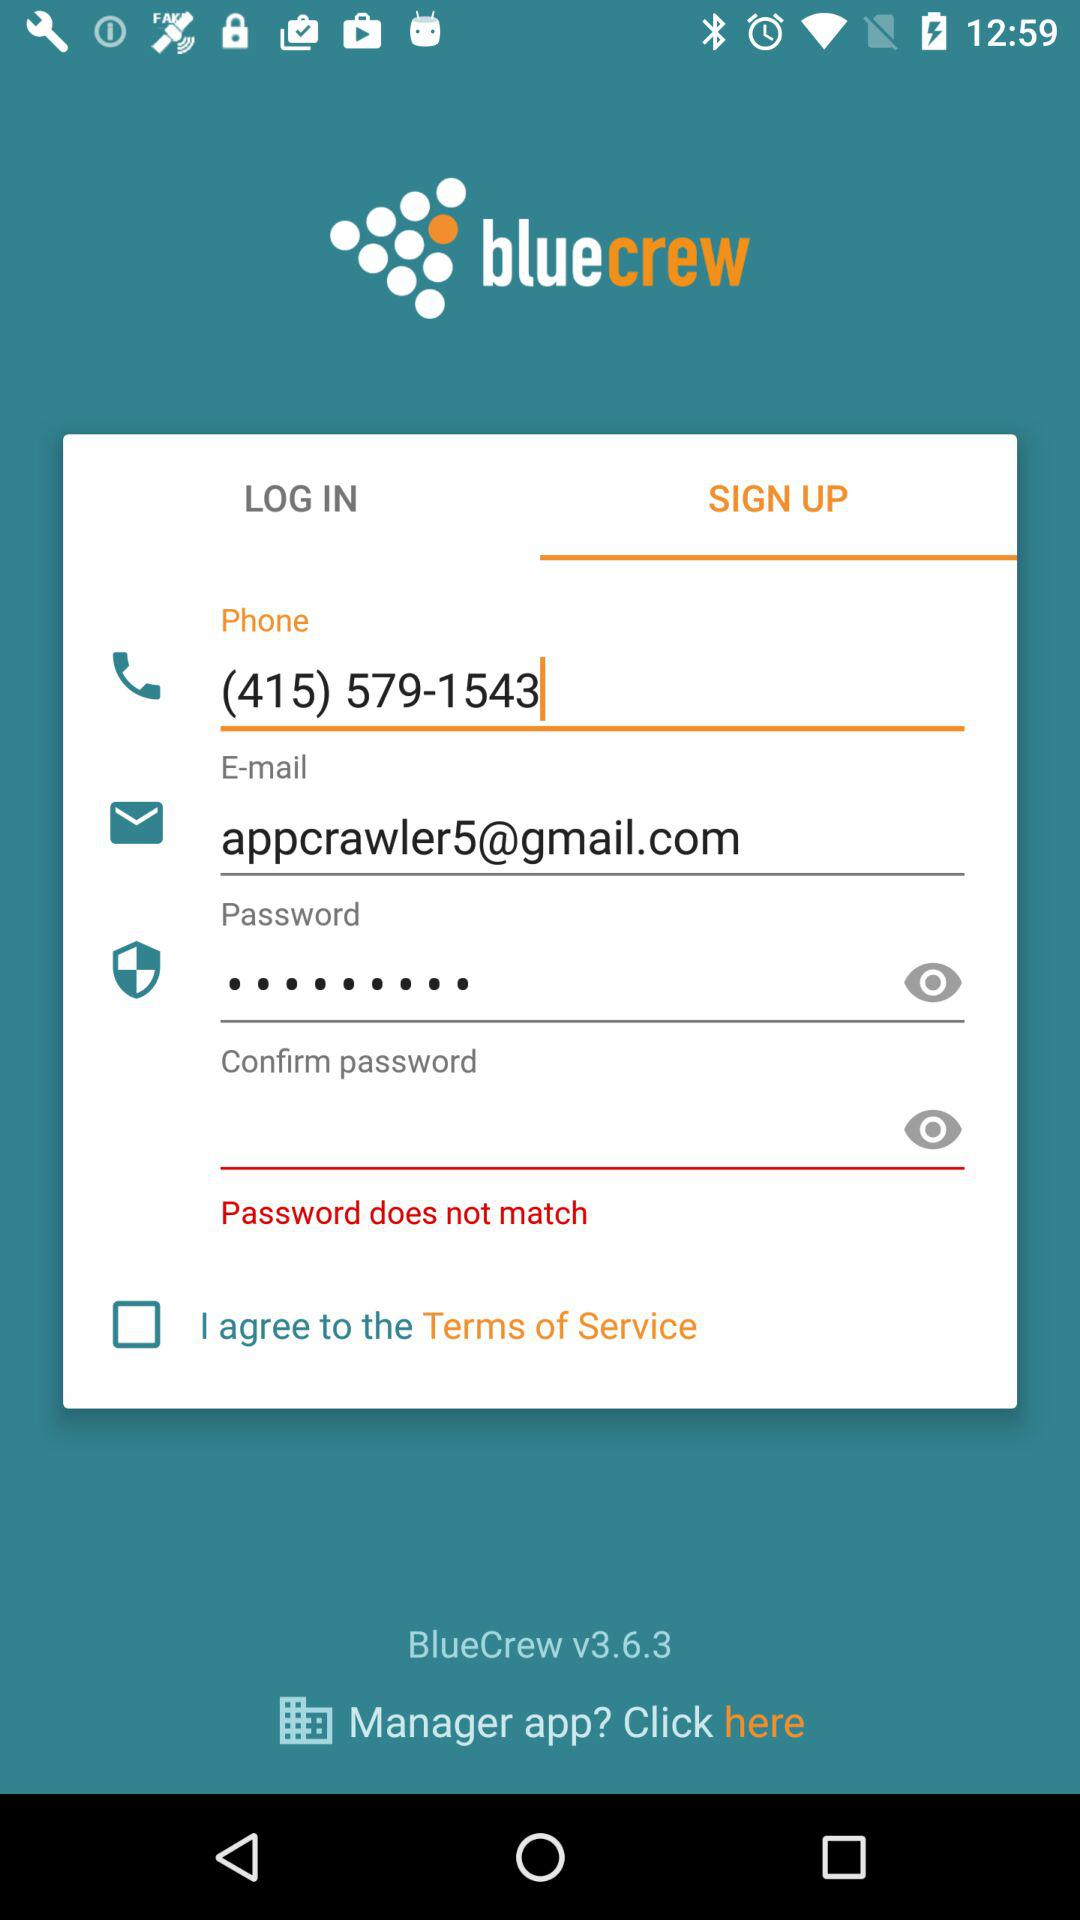What is the application name? The application name is "bluecrew". 